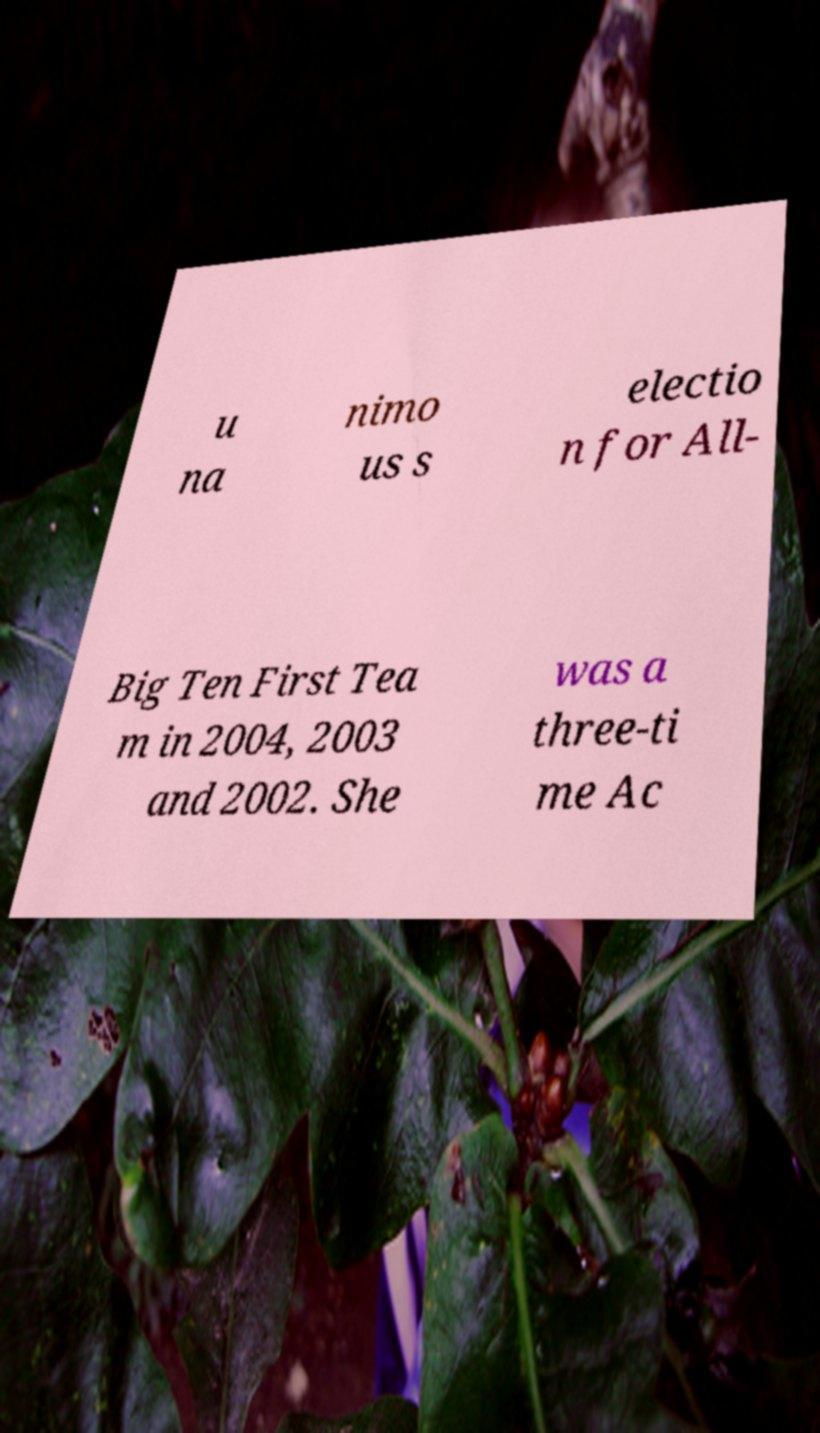Could you extract and type out the text from this image? u na nimo us s electio n for All- Big Ten First Tea m in 2004, 2003 and 2002. She was a three-ti me Ac 